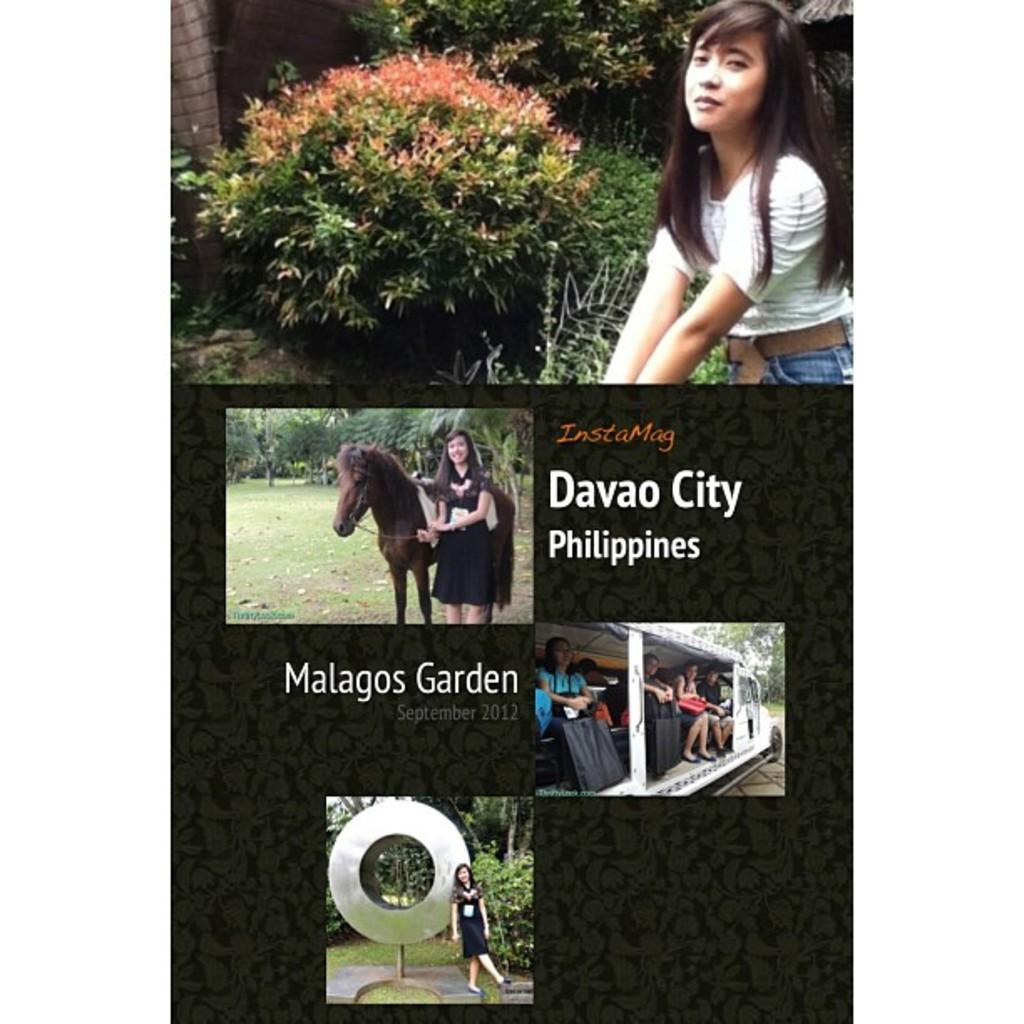What is the main subject of the picture? The main subject of the picture is an image. What can be seen in the image? There is a woman standing beside a horse in the image. What type of vegetation is visible in the image? There are plants visible in the image. Can you describe the people in the image? There are persons inside a vehicle in the image. What type of power is being generated by the horse in the image? There is no indication in the image that the horse is generating any power. Horses are not typically used for power generation. 